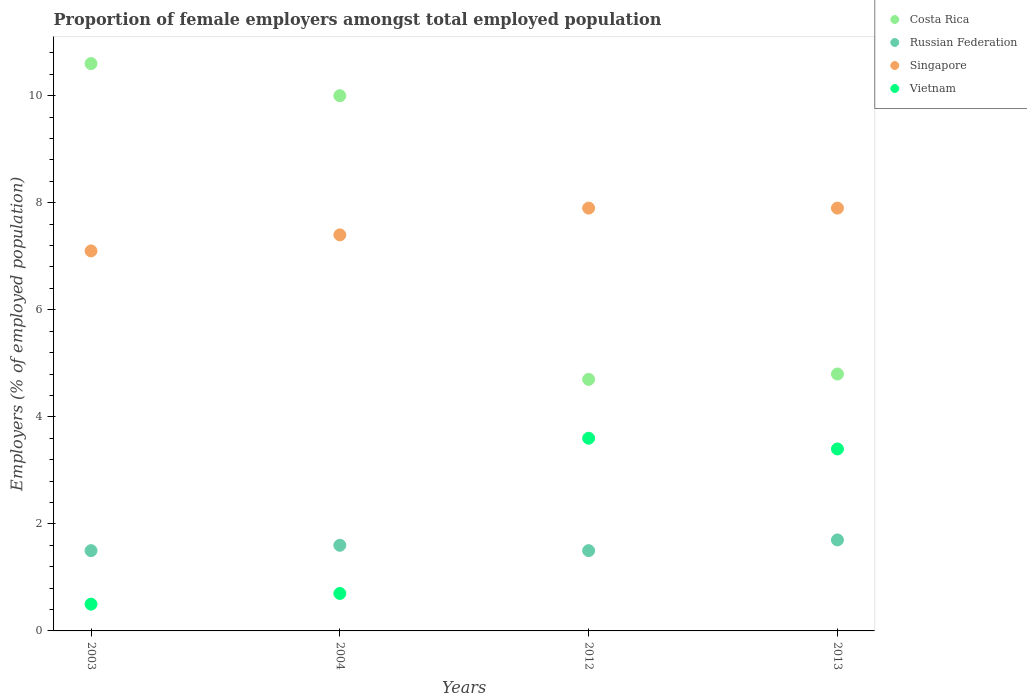How many different coloured dotlines are there?
Your answer should be very brief. 4. What is the proportion of female employers in Costa Rica in 2004?
Your response must be concise. 10. Across all years, what is the maximum proportion of female employers in Russian Federation?
Your answer should be very brief. 1.7. What is the total proportion of female employers in Vietnam in the graph?
Give a very brief answer. 8.2. What is the difference between the proportion of female employers in Singapore in 2013 and the proportion of female employers in Russian Federation in 2003?
Ensure brevity in your answer.  6.4. What is the average proportion of female employers in Singapore per year?
Offer a terse response. 7.58. In the year 2003, what is the difference between the proportion of female employers in Costa Rica and proportion of female employers in Vietnam?
Provide a short and direct response. 10.1. What is the ratio of the proportion of female employers in Vietnam in 2004 to that in 2012?
Make the answer very short. 0.19. Is the difference between the proportion of female employers in Costa Rica in 2003 and 2004 greater than the difference between the proportion of female employers in Vietnam in 2003 and 2004?
Offer a very short reply. Yes. What is the difference between the highest and the second highest proportion of female employers in Costa Rica?
Make the answer very short. 0.6. What is the difference between the highest and the lowest proportion of female employers in Vietnam?
Your answer should be very brief. 3.1. Is it the case that in every year, the sum of the proportion of female employers in Costa Rica and proportion of female employers in Vietnam  is greater than the proportion of female employers in Singapore?
Provide a succinct answer. Yes. Does the proportion of female employers in Russian Federation monotonically increase over the years?
Provide a succinct answer. No. How many dotlines are there?
Your answer should be very brief. 4. How many years are there in the graph?
Your response must be concise. 4. Are the values on the major ticks of Y-axis written in scientific E-notation?
Ensure brevity in your answer.  No. Does the graph contain grids?
Keep it short and to the point. No. How many legend labels are there?
Ensure brevity in your answer.  4. How are the legend labels stacked?
Keep it short and to the point. Vertical. What is the title of the graph?
Your answer should be very brief. Proportion of female employers amongst total employed population. What is the label or title of the Y-axis?
Ensure brevity in your answer.  Employers (% of employed population). What is the Employers (% of employed population) of Costa Rica in 2003?
Your response must be concise. 10.6. What is the Employers (% of employed population) in Singapore in 2003?
Ensure brevity in your answer.  7.1. What is the Employers (% of employed population) in Vietnam in 2003?
Your answer should be compact. 0.5. What is the Employers (% of employed population) of Russian Federation in 2004?
Ensure brevity in your answer.  1.6. What is the Employers (% of employed population) of Singapore in 2004?
Your answer should be compact. 7.4. What is the Employers (% of employed population) of Vietnam in 2004?
Give a very brief answer. 0.7. What is the Employers (% of employed population) of Costa Rica in 2012?
Keep it short and to the point. 4.7. What is the Employers (% of employed population) in Russian Federation in 2012?
Offer a very short reply. 1.5. What is the Employers (% of employed population) of Singapore in 2012?
Your answer should be compact. 7.9. What is the Employers (% of employed population) of Vietnam in 2012?
Make the answer very short. 3.6. What is the Employers (% of employed population) of Costa Rica in 2013?
Give a very brief answer. 4.8. What is the Employers (% of employed population) of Russian Federation in 2013?
Offer a very short reply. 1.7. What is the Employers (% of employed population) of Singapore in 2013?
Keep it short and to the point. 7.9. What is the Employers (% of employed population) in Vietnam in 2013?
Provide a succinct answer. 3.4. Across all years, what is the maximum Employers (% of employed population) of Costa Rica?
Make the answer very short. 10.6. Across all years, what is the maximum Employers (% of employed population) in Russian Federation?
Offer a terse response. 1.7. Across all years, what is the maximum Employers (% of employed population) of Singapore?
Offer a very short reply. 7.9. Across all years, what is the maximum Employers (% of employed population) in Vietnam?
Provide a short and direct response. 3.6. Across all years, what is the minimum Employers (% of employed population) in Costa Rica?
Provide a short and direct response. 4.7. Across all years, what is the minimum Employers (% of employed population) in Singapore?
Provide a short and direct response. 7.1. Across all years, what is the minimum Employers (% of employed population) in Vietnam?
Your response must be concise. 0.5. What is the total Employers (% of employed population) in Costa Rica in the graph?
Ensure brevity in your answer.  30.1. What is the total Employers (% of employed population) of Singapore in the graph?
Keep it short and to the point. 30.3. What is the difference between the Employers (% of employed population) in Costa Rica in 2003 and that in 2004?
Give a very brief answer. 0.6. What is the difference between the Employers (% of employed population) in Russian Federation in 2003 and that in 2012?
Keep it short and to the point. 0. What is the difference between the Employers (% of employed population) in Singapore in 2003 and that in 2012?
Provide a short and direct response. -0.8. What is the difference between the Employers (% of employed population) of Vietnam in 2003 and that in 2012?
Your answer should be very brief. -3.1. What is the difference between the Employers (% of employed population) in Costa Rica in 2003 and that in 2013?
Keep it short and to the point. 5.8. What is the difference between the Employers (% of employed population) of Russian Federation in 2003 and that in 2013?
Ensure brevity in your answer.  -0.2. What is the difference between the Employers (% of employed population) in Vietnam in 2003 and that in 2013?
Provide a short and direct response. -2.9. What is the difference between the Employers (% of employed population) of Russian Federation in 2004 and that in 2012?
Your response must be concise. 0.1. What is the difference between the Employers (% of employed population) in Costa Rica in 2004 and that in 2013?
Offer a very short reply. 5.2. What is the difference between the Employers (% of employed population) in Vietnam in 2012 and that in 2013?
Your response must be concise. 0.2. What is the difference between the Employers (% of employed population) of Costa Rica in 2003 and the Employers (% of employed population) of Russian Federation in 2004?
Offer a very short reply. 9. What is the difference between the Employers (% of employed population) in Costa Rica in 2003 and the Employers (% of employed population) in Vietnam in 2004?
Your answer should be compact. 9.9. What is the difference between the Employers (% of employed population) in Russian Federation in 2003 and the Employers (% of employed population) in Singapore in 2004?
Offer a very short reply. -5.9. What is the difference between the Employers (% of employed population) in Russian Federation in 2003 and the Employers (% of employed population) in Vietnam in 2004?
Offer a terse response. 0.8. What is the difference between the Employers (% of employed population) of Russian Federation in 2003 and the Employers (% of employed population) of Singapore in 2012?
Offer a very short reply. -6.4. What is the difference between the Employers (% of employed population) in Russian Federation in 2003 and the Employers (% of employed population) in Vietnam in 2013?
Provide a succinct answer. -1.9. What is the difference between the Employers (% of employed population) in Russian Federation in 2004 and the Employers (% of employed population) in Singapore in 2012?
Make the answer very short. -6.3. What is the difference between the Employers (% of employed population) in Costa Rica in 2004 and the Employers (% of employed population) in Russian Federation in 2013?
Make the answer very short. 8.3. What is the difference between the Employers (% of employed population) of Costa Rica in 2004 and the Employers (% of employed population) of Vietnam in 2013?
Provide a succinct answer. 6.6. What is the difference between the Employers (% of employed population) in Russian Federation in 2004 and the Employers (% of employed population) in Singapore in 2013?
Offer a very short reply. -6.3. What is the difference between the Employers (% of employed population) of Russian Federation in 2004 and the Employers (% of employed population) of Vietnam in 2013?
Provide a succinct answer. -1.8. What is the difference between the Employers (% of employed population) of Costa Rica in 2012 and the Employers (% of employed population) of Vietnam in 2013?
Provide a succinct answer. 1.3. What is the difference between the Employers (% of employed population) of Russian Federation in 2012 and the Employers (% of employed population) of Singapore in 2013?
Offer a terse response. -6.4. What is the difference between the Employers (% of employed population) in Russian Federation in 2012 and the Employers (% of employed population) in Vietnam in 2013?
Your answer should be very brief. -1.9. What is the difference between the Employers (% of employed population) in Singapore in 2012 and the Employers (% of employed population) in Vietnam in 2013?
Offer a terse response. 4.5. What is the average Employers (% of employed population) of Costa Rica per year?
Your response must be concise. 7.53. What is the average Employers (% of employed population) of Russian Federation per year?
Offer a terse response. 1.57. What is the average Employers (% of employed population) of Singapore per year?
Provide a short and direct response. 7.58. What is the average Employers (% of employed population) in Vietnam per year?
Provide a succinct answer. 2.05. In the year 2003, what is the difference between the Employers (% of employed population) in Costa Rica and Employers (% of employed population) in Russian Federation?
Your answer should be very brief. 9.1. In the year 2003, what is the difference between the Employers (% of employed population) of Costa Rica and Employers (% of employed population) of Singapore?
Your response must be concise. 3.5. In the year 2003, what is the difference between the Employers (% of employed population) in Costa Rica and Employers (% of employed population) in Vietnam?
Provide a short and direct response. 10.1. In the year 2003, what is the difference between the Employers (% of employed population) in Russian Federation and Employers (% of employed population) in Singapore?
Offer a terse response. -5.6. In the year 2003, what is the difference between the Employers (% of employed population) of Russian Federation and Employers (% of employed population) of Vietnam?
Keep it short and to the point. 1. In the year 2004, what is the difference between the Employers (% of employed population) in Costa Rica and Employers (% of employed population) in Russian Federation?
Ensure brevity in your answer.  8.4. In the year 2004, what is the difference between the Employers (% of employed population) in Costa Rica and Employers (% of employed population) in Vietnam?
Offer a terse response. 9.3. In the year 2012, what is the difference between the Employers (% of employed population) in Costa Rica and Employers (% of employed population) in Singapore?
Offer a terse response. -3.2. In the year 2012, what is the difference between the Employers (% of employed population) in Costa Rica and Employers (% of employed population) in Vietnam?
Your response must be concise. 1.1. In the year 2012, what is the difference between the Employers (% of employed population) of Singapore and Employers (% of employed population) of Vietnam?
Your response must be concise. 4.3. In the year 2013, what is the difference between the Employers (% of employed population) in Costa Rica and Employers (% of employed population) in Russian Federation?
Your response must be concise. 3.1. In the year 2013, what is the difference between the Employers (% of employed population) of Costa Rica and Employers (% of employed population) of Singapore?
Provide a succinct answer. -3.1. What is the ratio of the Employers (% of employed population) of Costa Rica in 2003 to that in 2004?
Your answer should be very brief. 1.06. What is the ratio of the Employers (% of employed population) of Singapore in 2003 to that in 2004?
Ensure brevity in your answer.  0.96. What is the ratio of the Employers (% of employed population) in Vietnam in 2003 to that in 2004?
Provide a succinct answer. 0.71. What is the ratio of the Employers (% of employed population) in Costa Rica in 2003 to that in 2012?
Your response must be concise. 2.26. What is the ratio of the Employers (% of employed population) in Singapore in 2003 to that in 2012?
Your response must be concise. 0.9. What is the ratio of the Employers (% of employed population) in Vietnam in 2003 to that in 2012?
Provide a short and direct response. 0.14. What is the ratio of the Employers (% of employed population) of Costa Rica in 2003 to that in 2013?
Provide a succinct answer. 2.21. What is the ratio of the Employers (% of employed population) in Russian Federation in 2003 to that in 2013?
Give a very brief answer. 0.88. What is the ratio of the Employers (% of employed population) in Singapore in 2003 to that in 2013?
Ensure brevity in your answer.  0.9. What is the ratio of the Employers (% of employed population) of Vietnam in 2003 to that in 2013?
Provide a succinct answer. 0.15. What is the ratio of the Employers (% of employed population) in Costa Rica in 2004 to that in 2012?
Offer a terse response. 2.13. What is the ratio of the Employers (% of employed population) in Russian Federation in 2004 to that in 2012?
Provide a short and direct response. 1.07. What is the ratio of the Employers (% of employed population) of Singapore in 2004 to that in 2012?
Offer a very short reply. 0.94. What is the ratio of the Employers (% of employed population) in Vietnam in 2004 to that in 2012?
Keep it short and to the point. 0.19. What is the ratio of the Employers (% of employed population) in Costa Rica in 2004 to that in 2013?
Your response must be concise. 2.08. What is the ratio of the Employers (% of employed population) in Russian Federation in 2004 to that in 2013?
Provide a succinct answer. 0.94. What is the ratio of the Employers (% of employed population) in Singapore in 2004 to that in 2013?
Your answer should be compact. 0.94. What is the ratio of the Employers (% of employed population) in Vietnam in 2004 to that in 2013?
Your answer should be compact. 0.21. What is the ratio of the Employers (% of employed population) in Costa Rica in 2012 to that in 2013?
Give a very brief answer. 0.98. What is the ratio of the Employers (% of employed population) of Russian Federation in 2012 to that in 2013?
Provide a short and direct response. 0.88. What is the ratio of the Employers (% of employed population) of Vietnam in 2012 to that in 2013?
Your answer should be compact. 1.06. What is the difference between the highest and the second highest Employers (% of employed population) of Costa Rica?
Provide a succinct answer. 0.6. What is the difference between the highest and the lowest Employers (% of employed population) in Costa Rica?
Provide a succinct answer. 5.9. What is the difference between the highest and the lowest Employers (% of employed population) in Russian Federation?
Your answer should be very brief. 0.2. What is the difference between the highest and the lowest Employers (% of employed population) in Vietnam?
Your answer should be compact. 3.1. 